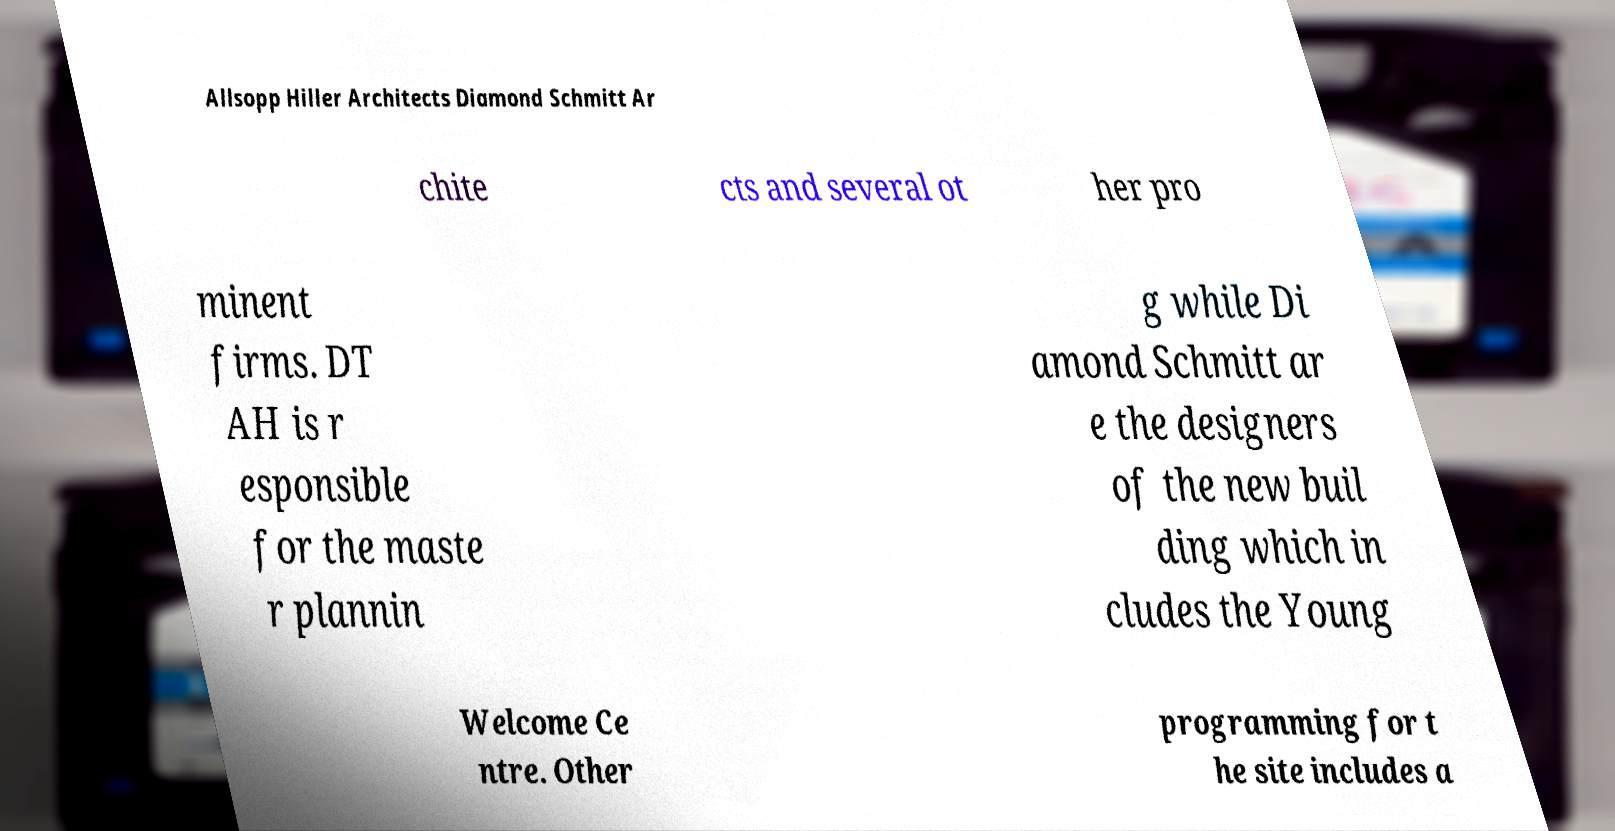For documentation purposes, I need the text within this image transcribed. Could you provide that? Allsopp Hiller Architects Diamond Schmitt Ar chite cts and several ot her pro minent firms. DT AH is r esponsible for the maste r plannin g while Di amond Schmitt ar e the designers of the new buil ding which in cludes the Young Welcome Ce ntre. Other programming for t he site includes a 